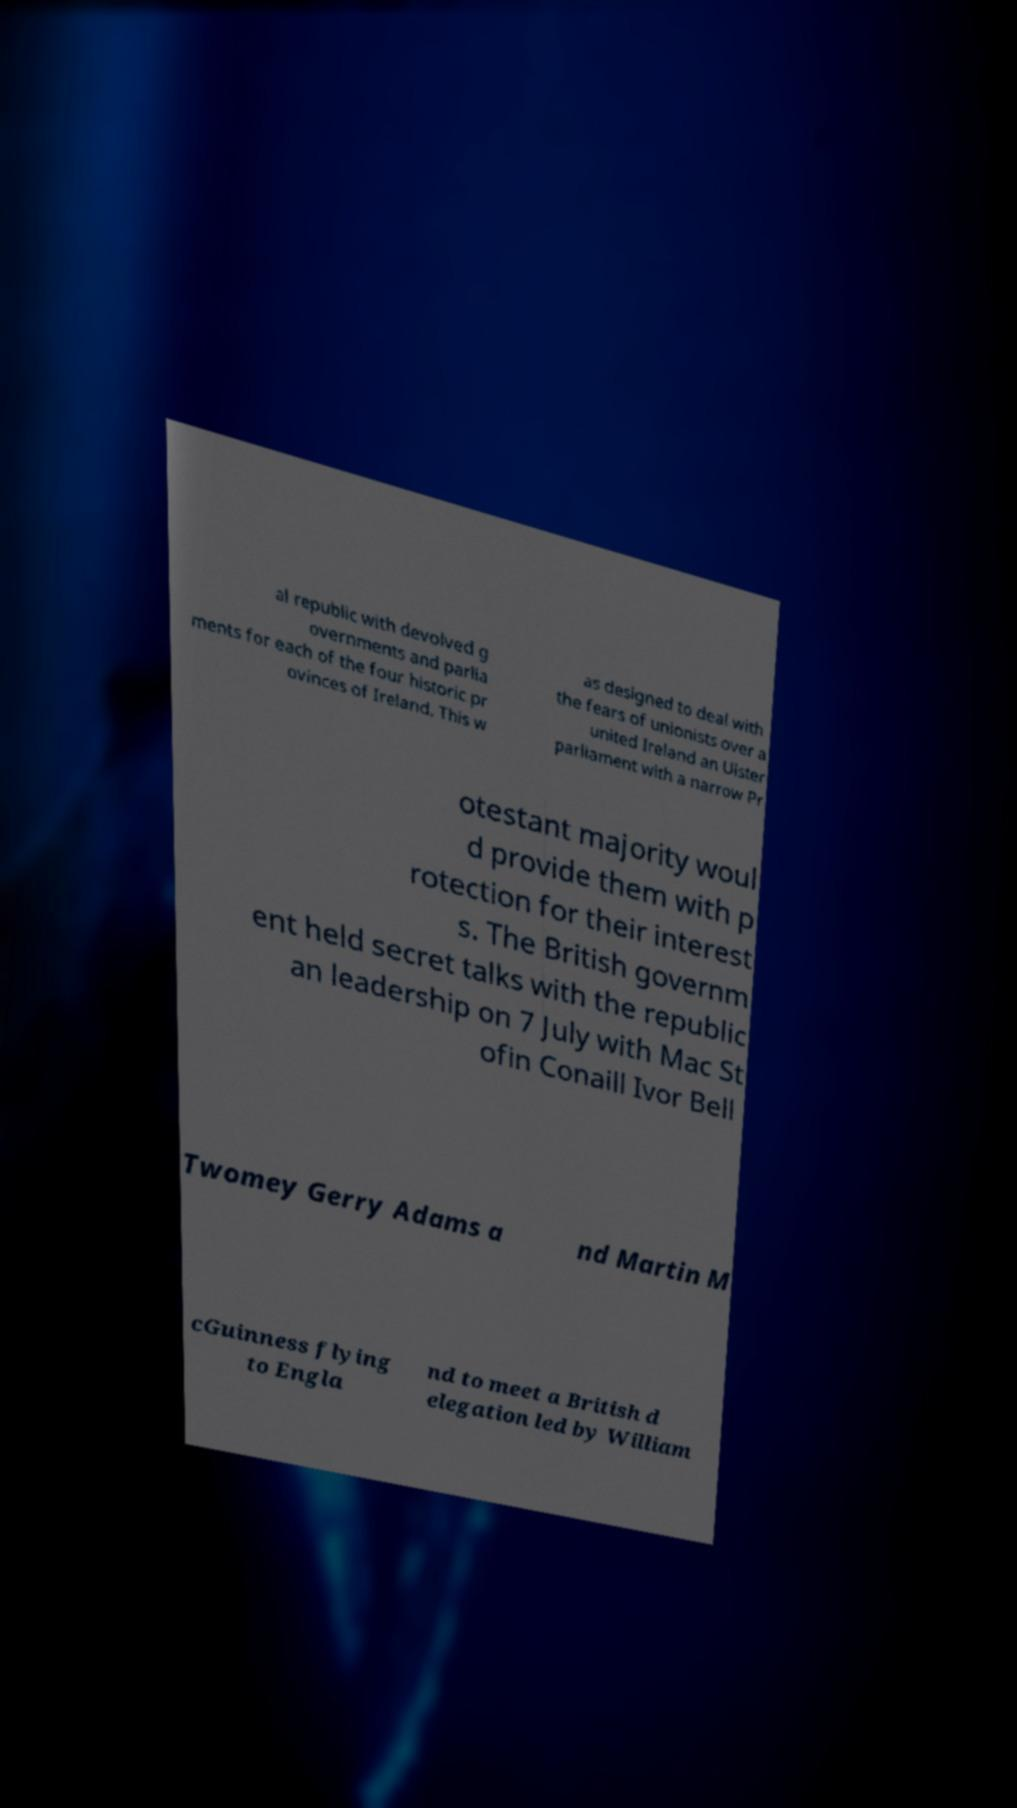Could you extract and type out the text from this image? al republic with devolved g overnments and parlia ments for each of the four historic pr ovinces of Ireland. This w as designed to deal with the fears of unionists over a united Ireland an Ulster parliament with a narrow Pr otestant majority woul d provide them with p rotection for their interest s. The British governm ent held secret talks with the republic an leadership on 7 July with Mac St ofin Conaill Ivor Bell Twomey Gerry Adams a nd Martin M cGuinness flying to Engla nd to meet a British d elegation led by William 